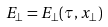Convert formula to latex. <formula><loc_0><loc_0><loc_500><loc_500>E _ { \perp } = E _ { \perp } ( \tau , x _ { \perp } )</formula> 